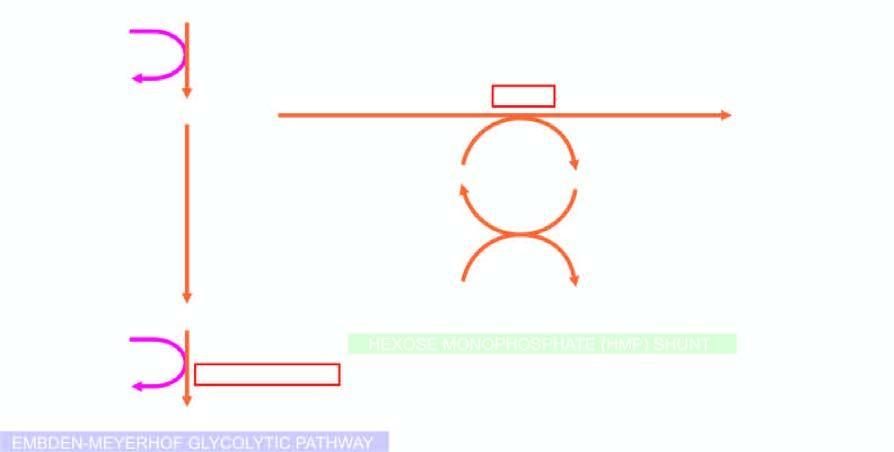how many red cell enzyme defects, glucose-6 phosphate dehydrogenase (g6pd) and pyruvate kinase, are shown bold?
Answer the question using a single word or phrase. Two 